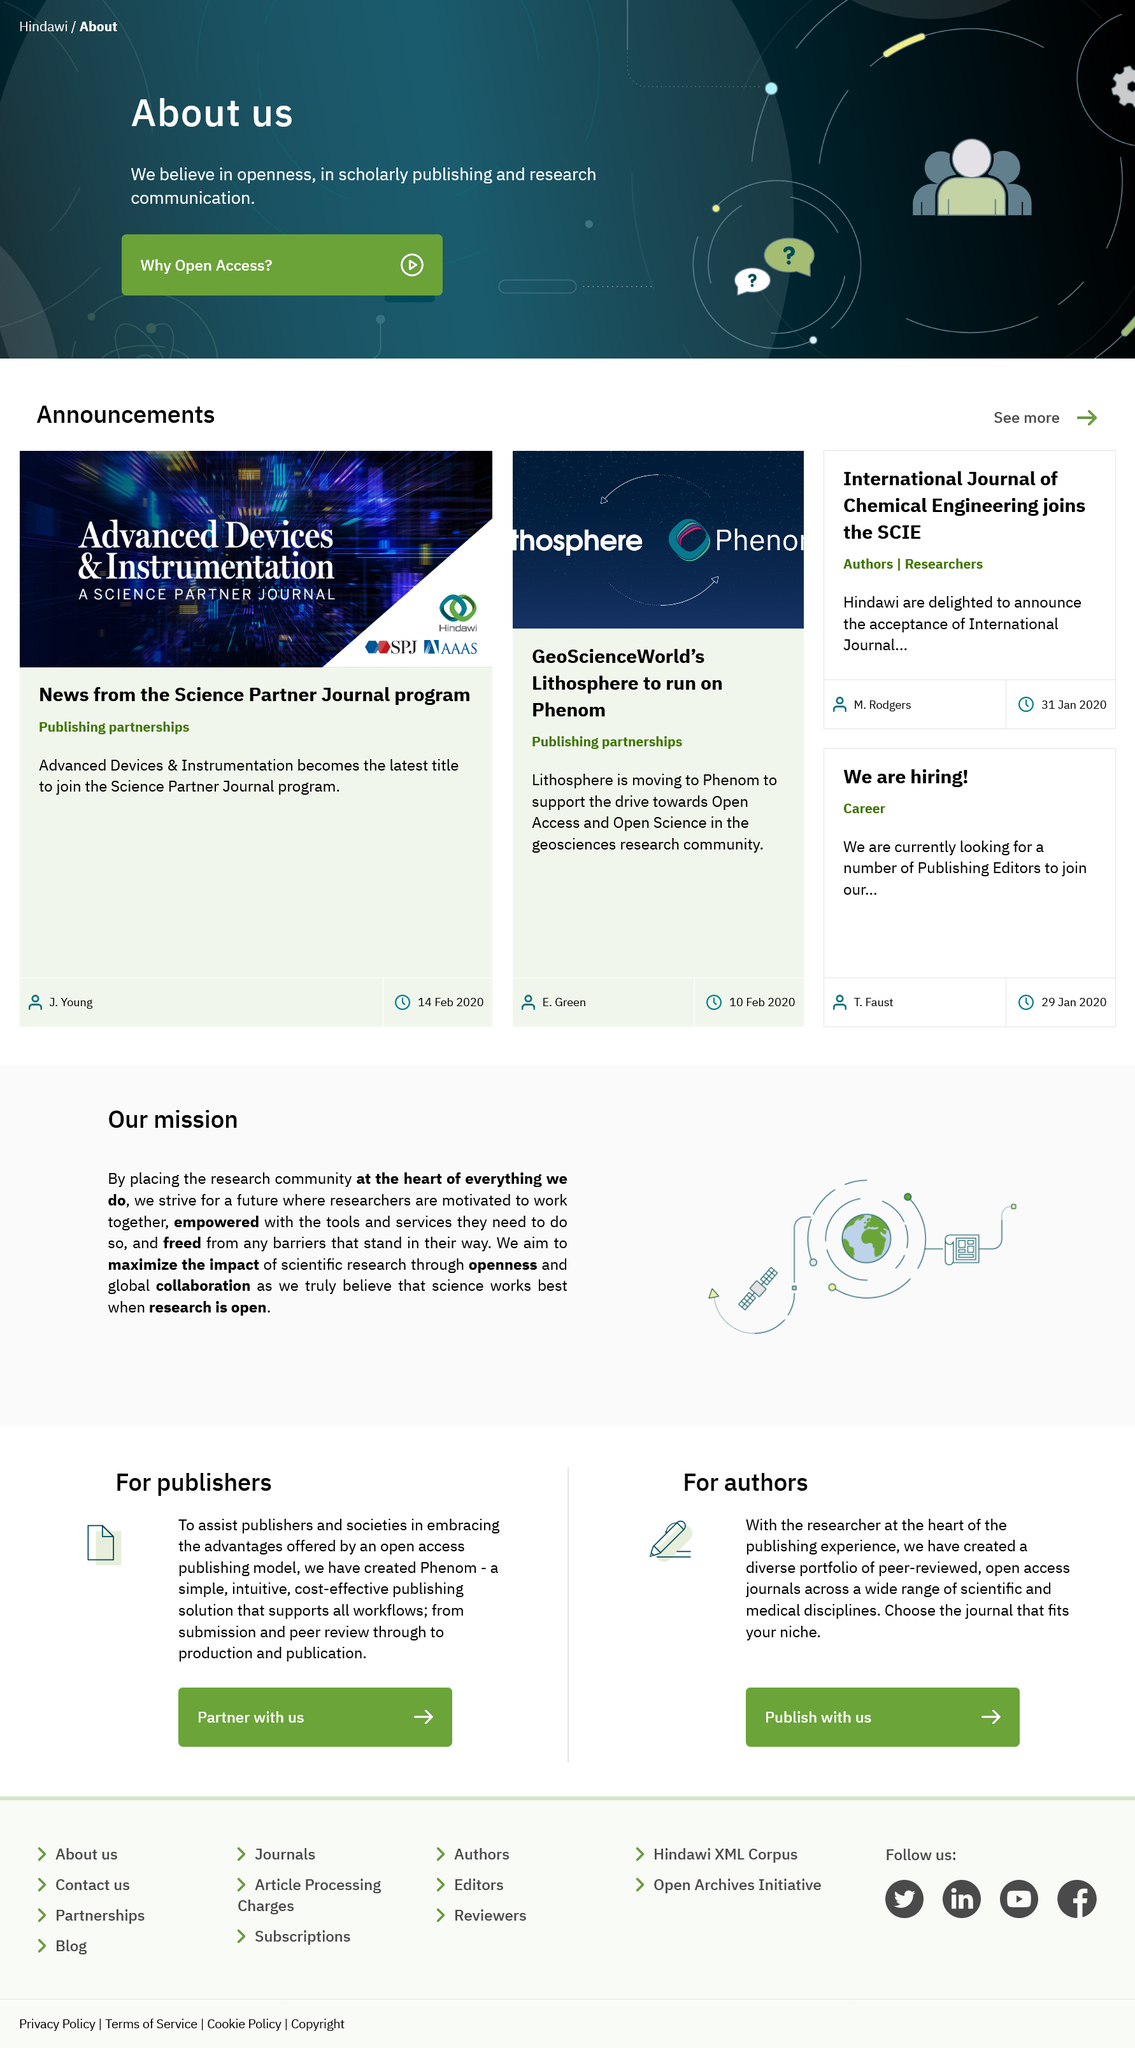List a handful of essential elements in this visual. The latest title to join the Science Partner Journal program is Advanced Devices & Instrumentation. Science research can be empowered through the provision of the necessary tools and services that enable scientists to carry out their research effectively. Authors can access scientific and medical journals from a variety of disciplines. Maximizing the impact of scientific research requires openness and global collaboration. Lithosphere is associated with the geosciences research community. 